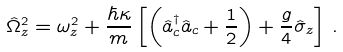Convert formula to latex. <formula><loc_0><loc_0><loc_500><loc_500>\hat { \Omega } ^ { 2 } _ { z } = \omega ^ { 2 } _ { z } + \frac { \hbar { \kappa } } { m } \left [ \left ( \hat { a } ^ { \dagger } _ { c } \hat { a } _ { c } + \frac { 1 } { 2 } \right ) + \frac { g } { 4 } \hat { \sigma } _ { z } \right ] \, .</formula> 